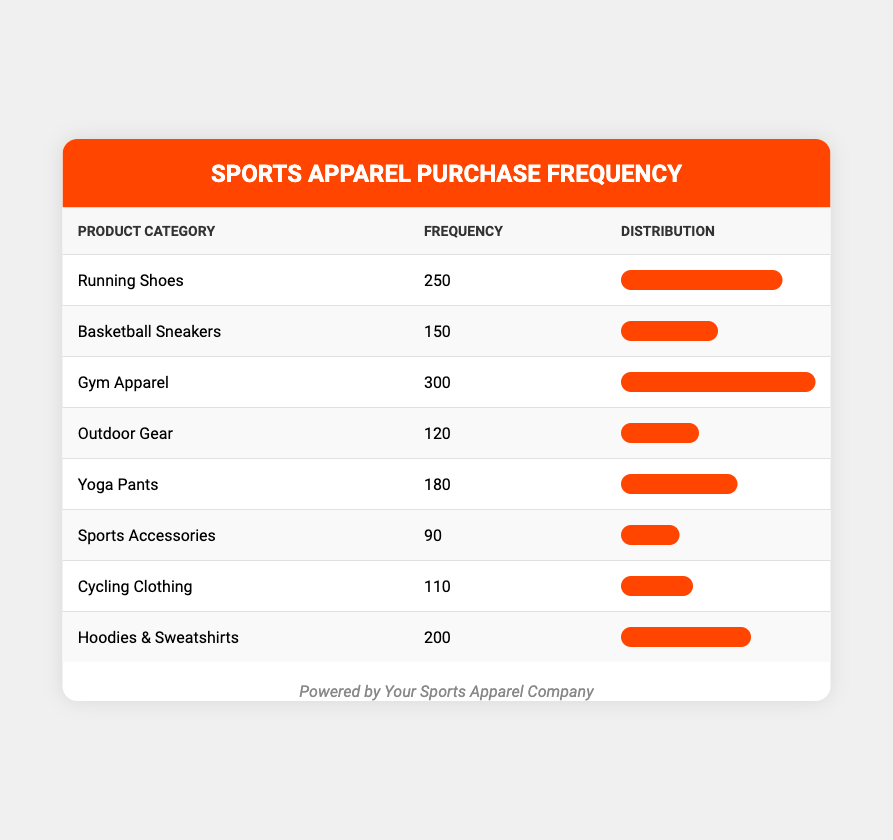What is the frequency of Gym Apparel purchases? The table directly lists the frequency of purchases for Gym Apparel as 300.
Answer: 300 Which product category has the lowest frequency of customer purchases? By reviewing the frequency values of all categories, Sports Accessories has the lowest frequency at 90.
Answer: Sports Accessories What is the total frequency of customer purchases for Running Shoes and Basketball Sneakers combined? The frequencies for Running Shoes (250) and Basketball Sneakers (150) can be summed: 250 + 150 = 400.
Answer: 400 Is the frequency of customer purchases for Yoga Pants greater than that for Cycling Clothing? The frequency for Yoga Pants is 180 and for Cycling Clothing is 110. Since 180 is greater than 110, the answer is yes.
Answer: Yes What is the average frequency of purchases across all product categories? To find the average, sum all frequencies: 250 + 150 + 300 + 120 + 180 + 90 + 110 + 200 = 1400. Since there are 8 categories, divide by 8: 1400 / 8 = 175.
Answer: 175 How many more purchases were made for Hoodies & Sweatshirts compared to Outdoor Gear? Hoodies & Sweatshirts have a frequency of 200 and Outdoor Gear has 120. The difference is calculated as 200 - 120 = 80.
Answer: 80 Which two categories have a combined frequency that exceeds 400? By checking combinations, Gym Apparel (300) and Running Shoes (250) exceed 400 when summed: 300 + 250 = 550. Thus, these two categories work.
Answer: Gym Apparel and Running Shoes What percentage of total purchases does Sports Accessories represent? First, calculate the total purchases (1400). Then, Sports Accessories has a frequency of 90. To find the percentage: (90 / 1400) * 100 = 6.43%.
Answer: 6.43% How many product categories have a frequency greater than 150? The product categories with a frequency greater than 150 are Running Shoes (250), Gym Apparel (300), and Hoodies & Sweatshirts (200), which totals 3 categories.
Answer: 3 